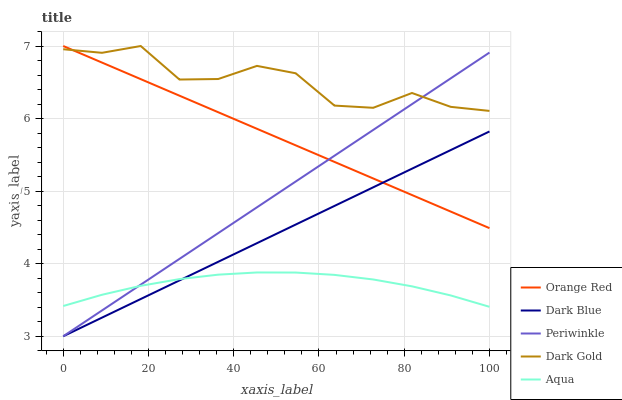Does Dark Blue have the minimum area under the curve?
Answer yes or no. No. Does Dark Blue have the maximum area under the curve?
Answer yes or no. No. Is Dark Blue the smoothest?
Answer yes or no. No. Is Dark Blue the roughest?
Answer yes or no. No. Does Orange Red have the lowest value?
Answer yes or no. No. Does Dark Blue have the highest value?
Answer yes or no. No. Is Dark Blue less than Dark Gold?
Answer yes or no. Yes. Is Orange Red greater than Aqua?
Answer yes or no. Yes. Does Dark Blue intersect Dark Gold?
Answer yes or no. No. 